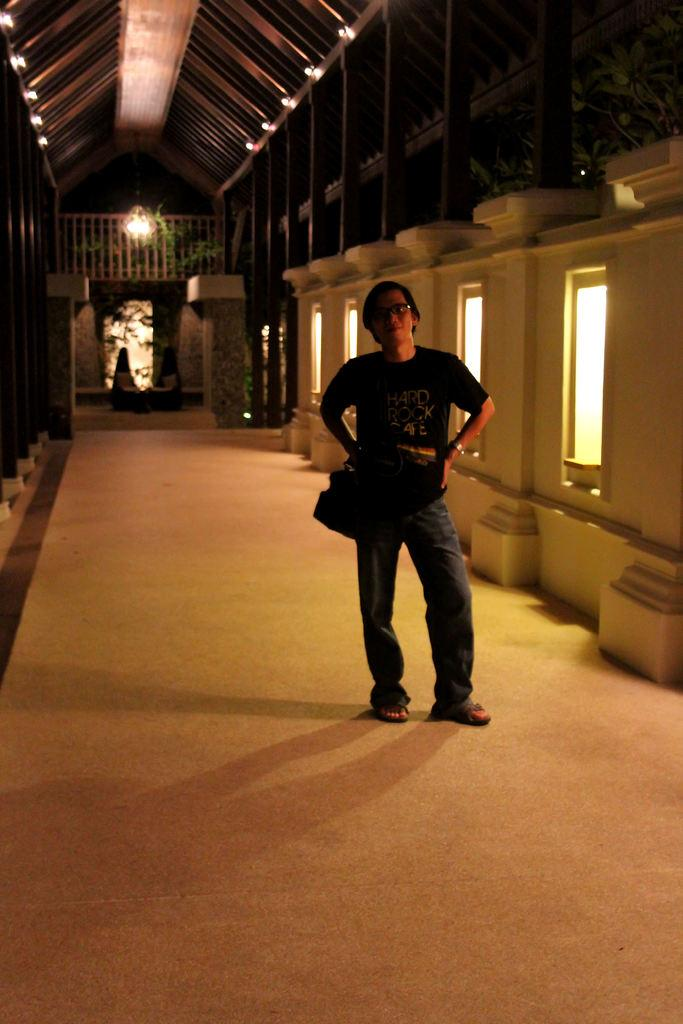What can be seen in the image? There is a person in the image. Can you describe the person's appearance? The person is wearing spectacles. Where is the person located in the image? The person is standing on the floor. What can be seen in the background of the image? There are windows, lights, pillars, a fence, plants, and some objects visible in the background. What type of destruction can be seen in the image? There is no destruction present in the image. 